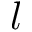Convert formula to latex. <formula><loc_0><loc_0><loc_500><loc_500>l</formula> 